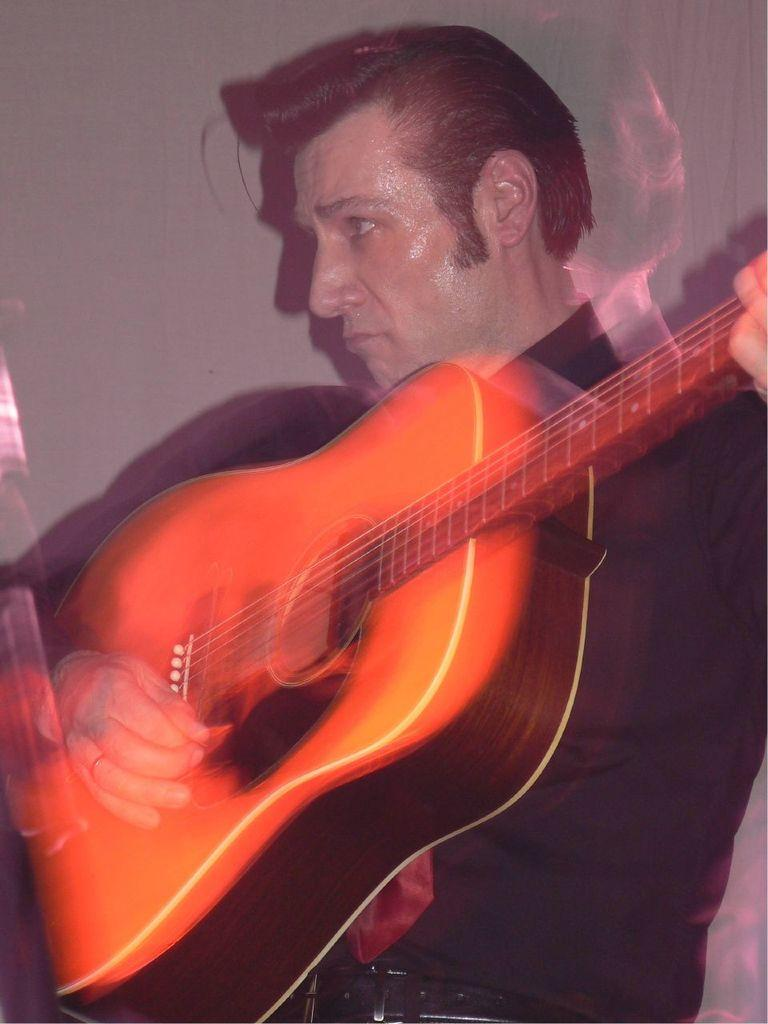What is the main subject of the image? The main subject of the image is a man. What is the man doing in the image? The man is playing a guitar in the image. Where is the kitten playing with a blade in the image? There is no kitten or blade present in the image; it only features a man playing a guitar. 